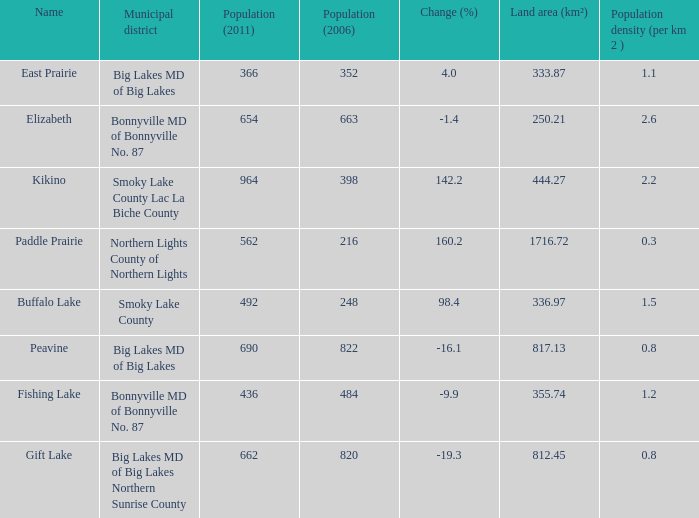What is the density per km in Smoky Lake County? 1.5. 